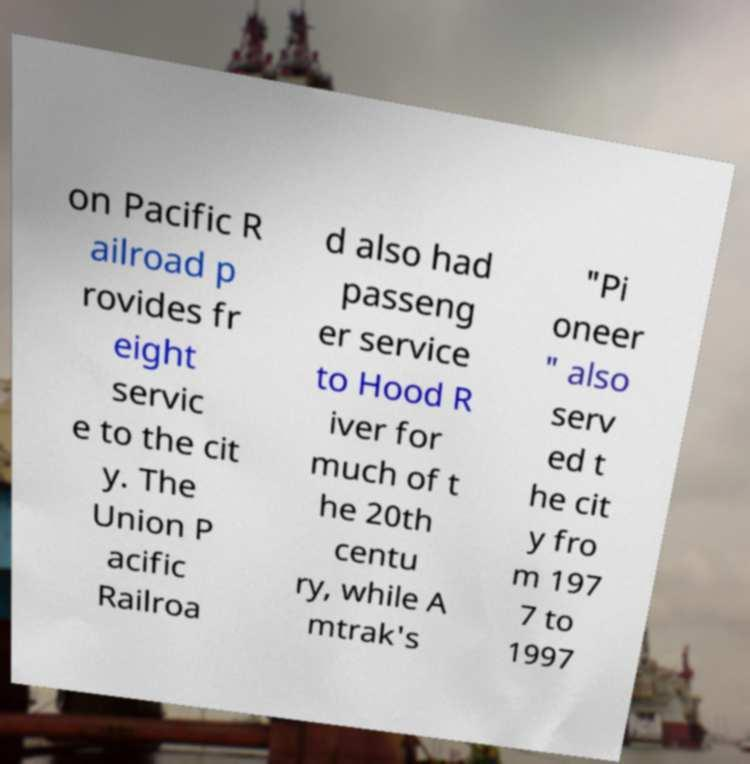Please identify and transcribe the text found in this image. on Pacific R ailroad p rovides fr eight servic e to the cit y. The Union P acific Railroa d also had passeng er service to Hood R iver for much of t he 20th centu ry, while A mtrak's "Pi oneer " also serv ed t he cit y fro m 197 7 to 1997 